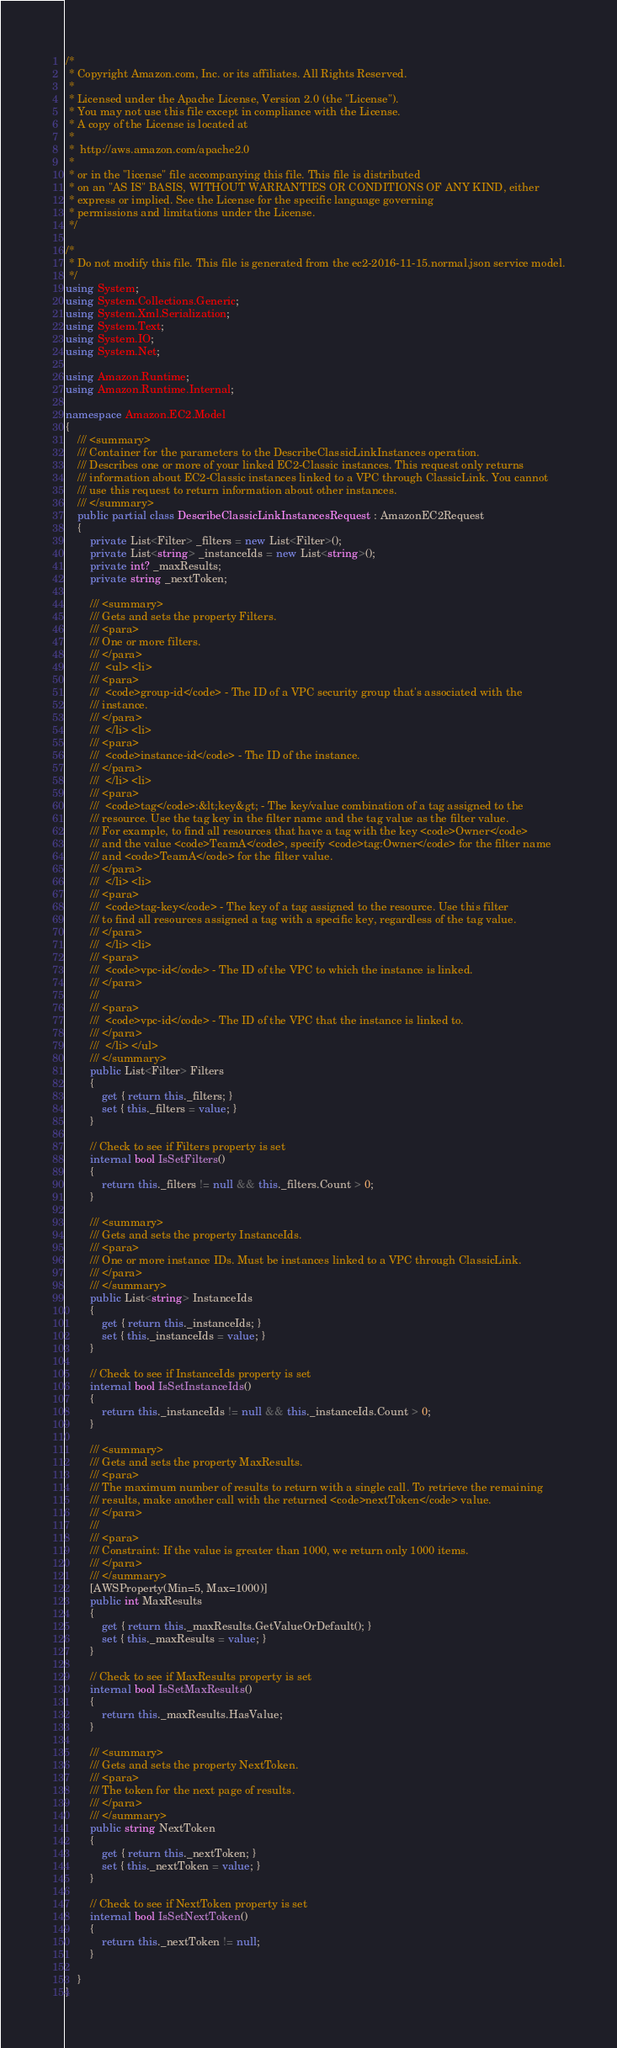<code> <loc_0><loc_0><loc_500><loc_500><_C#_>/*
 * Copyright Amazon.com, Inc. or its affiliates. All Rights Reserved.
 * 
 * Licensed under the Apache License, Version 2.0 (the "License").
 * You may not use this file except in compliance with the License.
 * A copy of the License is located at
 * 
 *  http://aws.amazon.com/apache2.0
 * 
 * or in the "license" file accompanying this file. This file is distributed
 * on an "AS IS" BASIS, WITHOUT WARRANTIES OR CONDITIONS OF ANY KIND, either
 * express or implied. See the License for the specific language governing
 * permissions and limitations under the License.
 */

/*
 * Do not modify this file. This file is generated from the ec2-2016-11-15.normal.json service model.
 */
using System;
using System.Collections.Generic;
using System.Xml.Serialization;
using System.Text;
using System.IO;
using System.Net;

using Amazon.Runtime;
using Amazon.Runtime.Internal;

namespace Amazon.EC2.Model
{
    /// <summary>
    /// Container for the parameters to the DescribeClassicLinkInstances operation.
    /// Describes one or more of your linked EC2-Classic instances. This request only returns
    /// information about EC2-Classic instances linked to a VPC through ClassicLink. You cannot
    /// use this request to return information about other instances.
    /// </summary>
    public partial class DescribeClassicLinkInstancesRequest : AmazonEC2Request
    {
        private List<Filter> _filters = new List<Filter>();
        private List<string> _instanceIds = new List<string>();
        private int? _maxResults;
        private string _nextToken;

        /// <summary>
        /// Gets and sets the property Filters. 
        /// <para>
        /// One or more filters.
        /// </para>
        ///  <ul> <li> 
        /// <para>
        ///  <code>group-id</code> - The ID of a VPC security group that's associated with the
        /// instance.
        /// </para>
        ///  </li> <li> 
        /// <para>
        ///  <code>instance-id</code> - The ID of the instance.
        /// </para>
        ///  </li> <li> 
        /// <para>
        ///  <code>tag</code>:&lt;key&gt; - The key/value combination of a tag assigned to the
        /// resource. Use the tag key in the filter name and the tag value as the filter value.
        /// For example, to find all resources that have a tag with the key <code>Owner</code>
        /// and the value <code>TeamA</code>, specify <code>tag:Owner</code> for the filter name
        /// and <code>TeamA</code> for the filter value.
        /// </para>
        ///  </li> <li> 
        /// <para>
        ///  <code>tag-key</code> - The key of a tag assigned to the resource. Use this filter
        /// to find all resources assigned a tag with a specific key, regardless of the tag value.
        /// </para>
        ///  </li> <li> 
        /// <para>
        ///  <code>vpc-id</code> - The ID of the VPC to which the instance is linked.
        /// </para>
        ///  
        /// <para>
        ///  <code>vpc-id</code> - The ID of the VPC that the instance is linked to.
        /// </para>
        ///  </li> </ul>
        /// </summary>
        public List<Filter> Filters
        {
            get { return this._filters; }
            set { this._filters = value; }
        }

        // Check to see if Filters property is set
        internal bool IsSetFilters()
        {
            return this._filters != null && this._filters.Count > 0; 
        }

        /// <summary>
        /// Gets and sets the property InstanceIds. 
        /// <para>
        /// One or more instance IDs. Must be instances linked to a VPC through ClassicLink.
        /// </para>
        /// </summary>
        public List<string> InstanceIds
        {
            get { return this._instanceIds; }
            set { this._instanceIds = value; }
        }

        // Check to see if InstanceIds property is set
        internal bool IsSetInstanceIds()
        {
            return this._instanceIds != null && this._instanceIds.Count > 0; 
        }

        /// <summary>
        /// Gets and sets the property MaxResults. 
        /// <para>
        /// The maximum number of results to return with a single call. To retrieve the remaining
        /// results, make another call with the returned <code>nextToken</code> value.
        /// </para>
        ///  
        /// <para>
        /// Constraint: If the value is greater than 1000, we return only 1000 items.
        /// </para>
        /// </summary>
        [AWSProperty(Min=5, Max=1000)]
        public int MaxResults
        {
            get { return this._maxResults.GetValueOrDefault(); }
            set { this._maxResults = value; }
        }

        // Check to see if MaxResults property is set
        internal bool IsSetMaxResults()
        {
            return this._maxResults.HasValue; 
        }

        /// <summary>
        /// Gets and sets the property NextToken. 
        /// <para>
        /// The token for the next page of results.
        /// </para>
        /// </summary>
        public string NextToken
        {
            get { return this._nextToken; }
            set { this._nextToken = value; }
        }

        // Check to see if NextToken property is set
        internal bool IsSetNextToken()
        {
            return this._nextToken != null;
        }

    }
}</code> 